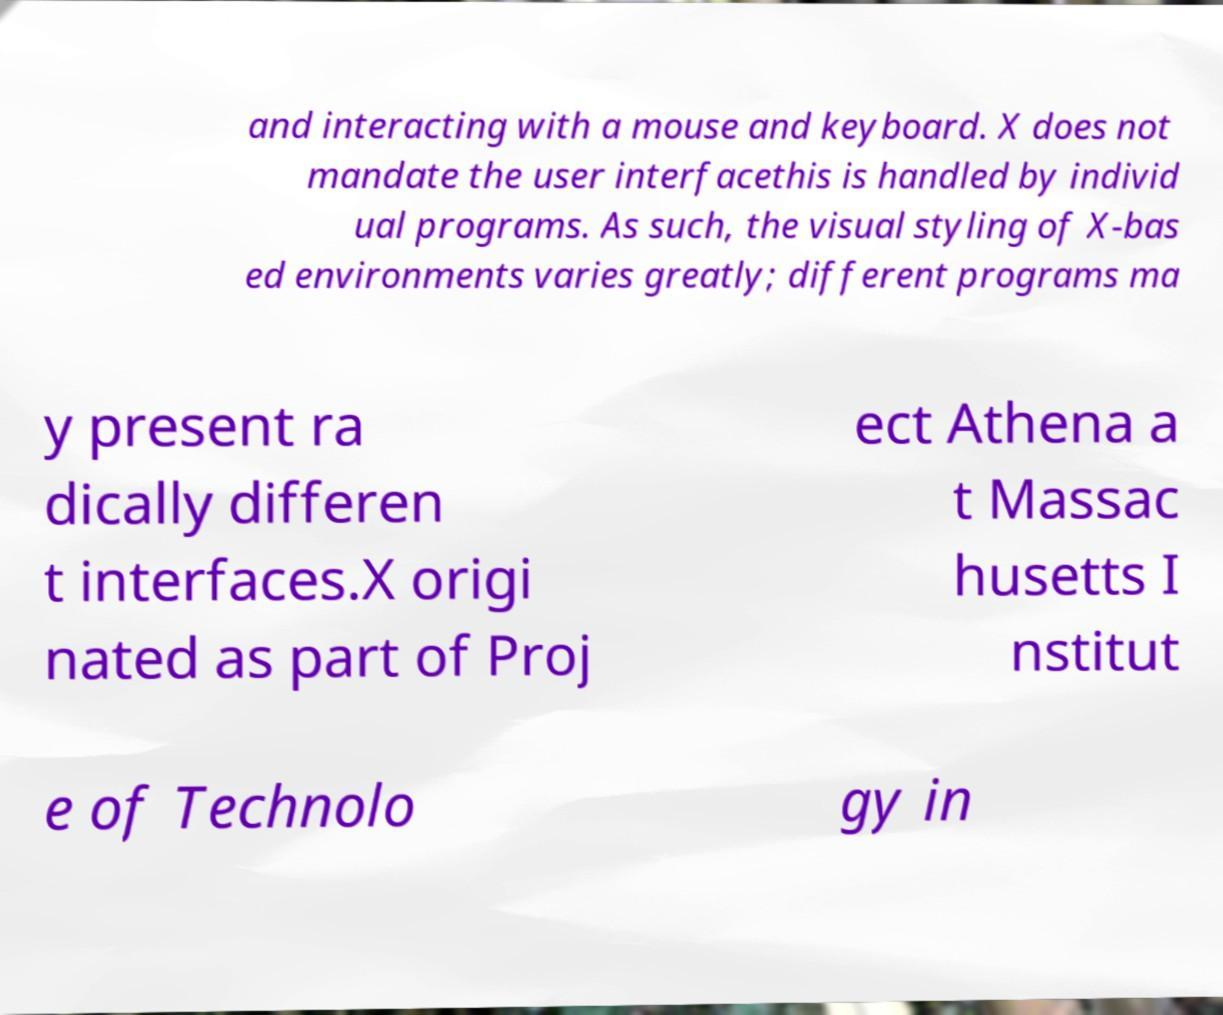Could you extract and type out the text from this image? and interacting with a mouse and keyboard. X does not mandate the user interfacethis is handled by individ ual programs. As such, the visual styling of X-bas ed environments varies greatly; different programs ma y present ra dically differen t interfaces.X origi nated as part of Proj ect Athena a t Massac husetts I nstitut e of Technolo gy in 